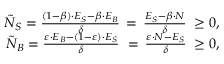<formula> <loc_0><loc_0><loc_500><loc_500>\begin{array} { r l r } & { \tilde { N } _ { S } = \frac { ( 1 - \beta ) \cdot E _ { S } - \beta \cdot E _ { B } } { \delta } \, = \, \frac { E _ { S } - \beta \cdot N } { \delta } \, \geq 0 , } \\ & { \tilde { N } _ { B } = \frac { \varepsilon \cdot E _ { B } - ( 1 - \varepsilon ) \cdot E _ { S } } { \delta } \, = \, \frac { \varepsilon \cdot N - E _ { S } } { \delta } \, \geq 0 , } \end{array}</formula> 